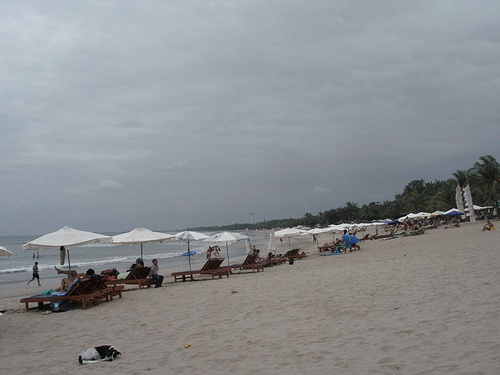Describe the objects in this image and their specific colors. I can see umbrella in lightgray, black, gray, and darkgray tones, people in lightgray, black, gray, and maroon tones, umbrella in lightgray, darkgray, and gray tones, chair in lightgray, black, maroon, and gray tones, and umbrella in lightgray, darkgray, and gray tones in this image. 